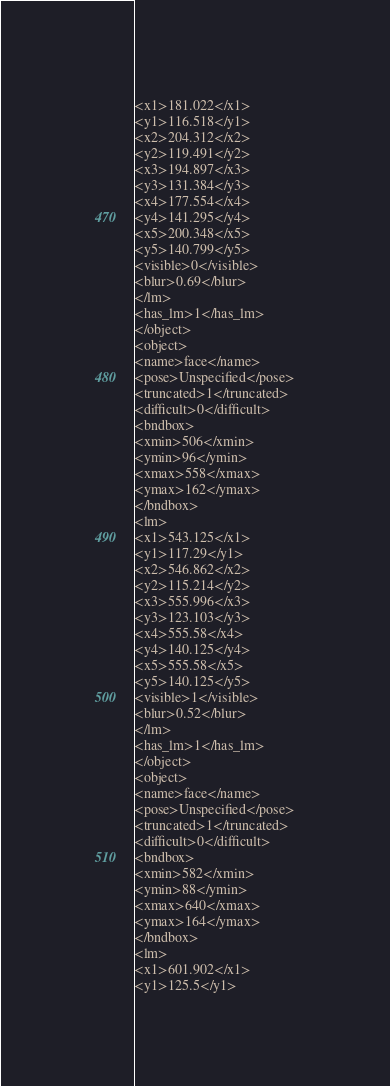Convert code to text. <code><loc_0><loc_0><loc_500><loc_500><_XML_><x1>181.022</x1>
<y1>116.518</y1>
<x2>204.312</x2>
<y2>119.491</y2>
<x3>194.897</x3>
<y3>131.384</y3>
<x4>177.554</x4>
<y4>141.295</y4>
<x5>200.348</x5>
<y5>140.799</y5>
<visible>0</visible>
<blur>0.69</blur>
</lm>
<has_lm>1</has_lm>
</object>
<object>
<name>face</name>
<pose>Unspecified</pose>
<truncated>1</truncated>
<difficult>0</difficult>
<bndbox>
<xmin>506</xmin>
<ymin>96</ymin>
<xmax>558</xmax>
<ymax>162</ymax>
</bndbox>
<lm>
<x1>543.125</x1>
<y1>117.29</y1>
<x2>546.862</x2>
<y2>115.214</y2>
<x3>555.996</x3>
<y3>123.103</y3>
<x4>555.58</x4>
<y4>140.125</y4>
<x5>555.58</x5>
<y5>140.125</y5>
<visible>1</visible>
<blur>0.52</blur>
</lm>
<has_lm>1</has_lm>
</object>
<object>
<name>face</name>
<pose>Unspecified</pose>
<truncated>1</truncated>
<difficult>0</difficult>
<bndbox>
<xmin>582</xmin>
<ymin>88</ymin>
<xmax>640</xmax>
<ymax>164</ymax>
</bndbox>
<lm>
<x1>601.902</x1>
<y1>125.5</y1></code> 